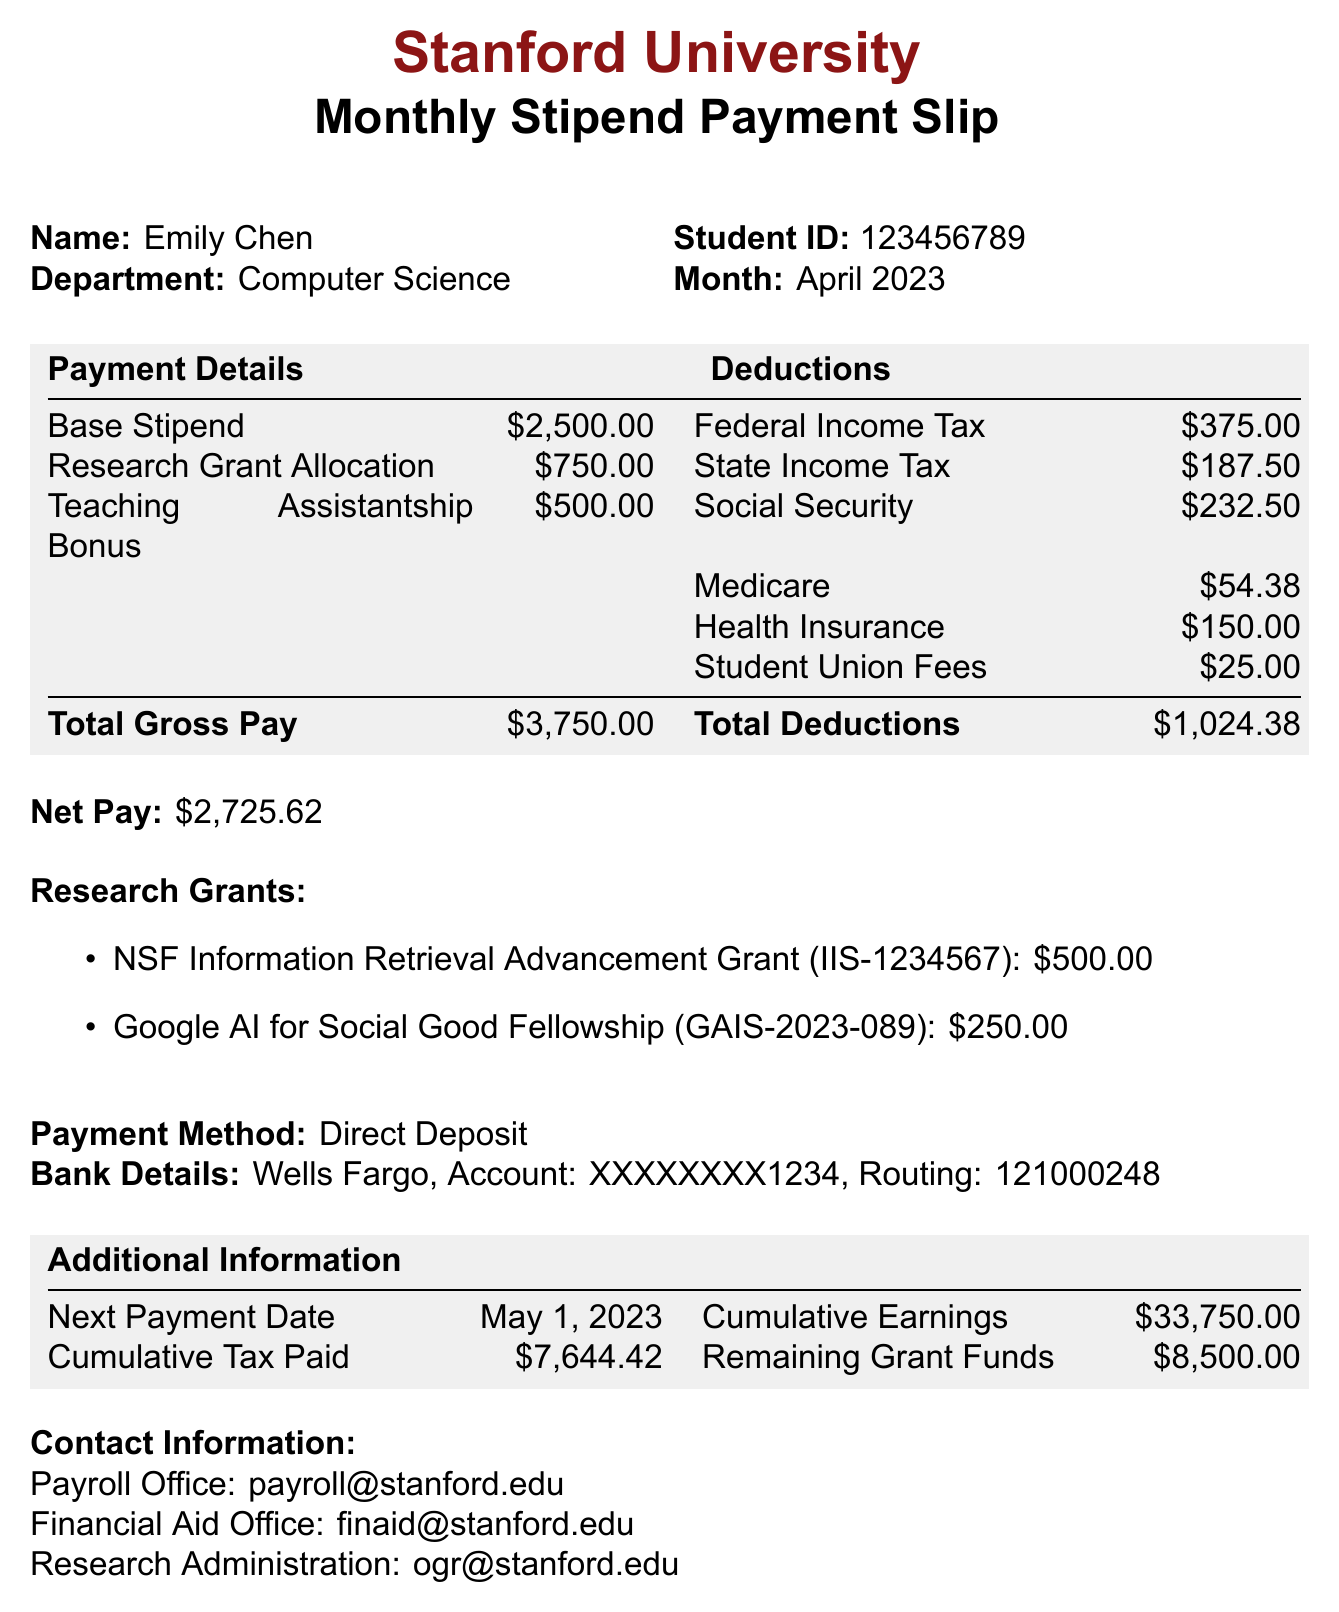What is the student's name? The student's name is stated in the document under the name section, which is Emily Chen.
Answer: Emily Chen What is the total gross pay for April 2023? The total gross pay is indicated in the payment details section of the document, listed as $3,750.00.
Answer: $3,750.00 How much is the federal income tax deduction? The federal income tax deduction can be found in the deductions section and is specified as $375.00.
Answer: $375.00 What is the remaining grant funds amount? The remaining grant funds are shown in the additional information section, which indicates $8,500.00.
Answer: $8,500.00 Which grant has the number IIS-1234567? The grant number IIS-1234567 is associated with the NSF Information Retrieval Advancement Grant.
Answer: NSF Information Retrieval Advancement Grant What is the cumulative tax paid up to April 2023? The document lists cumulative tax paid as $7,644.42 in the additional information section.
Answer: $7,644.42 What is the payment method for the stipend? The payment method is clearly stated in the document as Direct Deposit.
Answer: Direct Deposit How much is the teaching assistantship bonus? The teaching assistantship bonus is outlined in the payment details section, amounting to $500.00.
Answer: $500.00 What email address can be used to contact the payroll office? The email for the payroll office is specified in the document as payroll@stanford.edu.
Answer: payroll@stanford.edu 